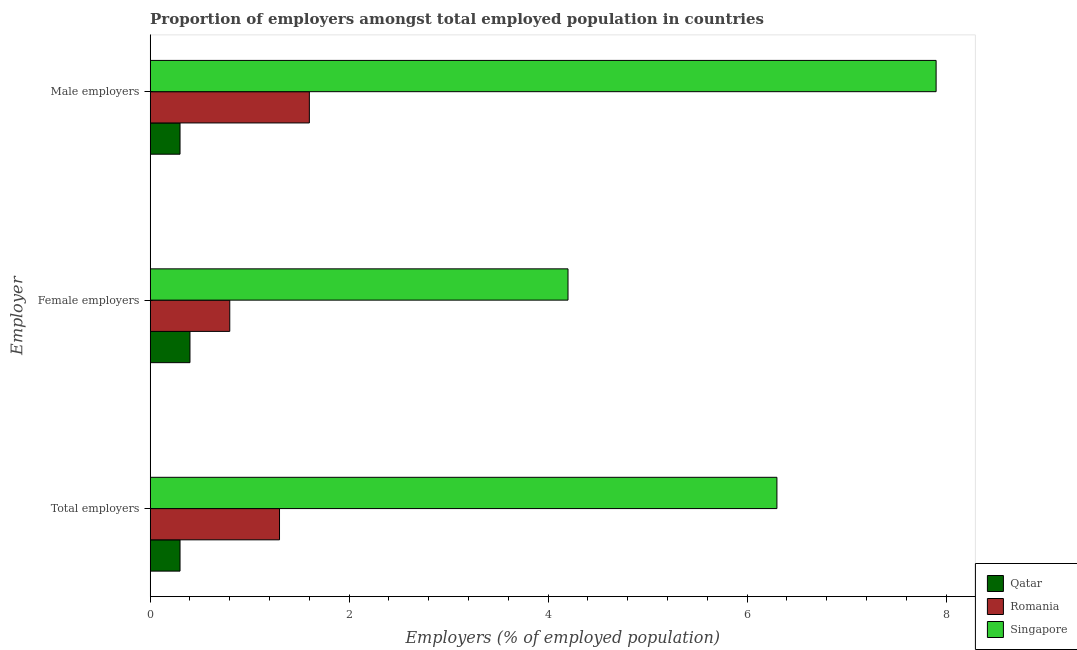How many groups of bars are there?
Make the answer very short. 3. Are the number of bars on each tick of the Y-axis equal?
Make the answer very short. Yes. What is the label of the 2nd group of bars from the top?
Ensure brevity in your answer.  Female employers. What is the percentage of total employers in Qatar?
Your response must be concise. 0.3. Across all countries, what is the maximum percentage of female employers?
Give a very brief answer. 4.2. Across all countries, what is the minimum percentage of male employers?
Your response must be concise. 0.3. In which country was the percentage of male employers maximum?
Keep it short and to the point. Singapore. In which country was the percentage of total employers minimum?
Keep it short and to the point. Qatar. What is the total percentage of male employers in the graph?
Ensure brevity in your answer.  9.8. What is the difference between the percentage of male employers in Romania and that in Singapore?
Provide a short and direct response. -6.3. What is the difference between the percentage of male employers in Romania and the percentage of total employers in Singapore?
Make the answer very short. -4.7. What is the average percentage of total employers per country?
Provide a short and direct response. 2.63. What is the difference between the percentage of male employers and percentage of total employers in Romania?
Offer a very short reply. 0.3. What is the ratio of the percentage of male employers in Singapore to that in Romania?
Offer a very short reply. 4.94. What is the difference between the highest and the second highest percentage of male employers?
Provide a succinct answer. 6.3. What is the difference between the highest and the lowest percentage of female employers?
Your answer should be very brief. 3.8. In how many countries, is the percentage of total employers greater than the average percentage of total employers taken over all countries?
Offer a terse response. 1. What does the 1st bar from the top in Female employers represents?
Provide a succinct answer. Singapore. What does the 3rd bar from the bottom in Total employers represents?
Make the answer very short. Singapore. How many bars are there?
Your response must be concise. 9. Are all the bars in the graph horizontal?
Your answer should be compact. Yes. Does the graph contain grids?
Provide a succinct answer. No. Where does the legend appear in the graph?
Offer a very short reply. Bottom right. How many legend labels are there?
Provide a succinct answer. 3. How are the legend labels stacked?
Offer a very short reply. Vertical. What is the title of the graph?
Your answer should be very brief. Proportion of employers amongst total employed population in countries. What is the label or title of the X-axis?
Provide a succinct answer. Employers (% of employed population). What is the label or title of the Y-axis?
Your response must be concise. Employer. What is the Employers (% of employed population) of Qatar in Total employers?
Ensure brevity in your answer.  0.3. What is the Employers (% of employed population) in Romania in Total employers?
Your answer should be compact. 1.3. What is the Employers (% of employed population) in Singapore in Total employers?
Provide a short and direct response. 6.3. What is the Employers (% of employed population) of Qatar in Female employers?
Give a very brief answer. 0.4. What is the Employers (% of employed population) of Romania in Female employers?
Give a very brief answer. 0.8. What is the Employers (% of employed population) in Singapore in Female employers?
Your answer should be compact. 4.2. What is the Employers (% of employed population) of Qatar in Male employers?
Make the answer very short. 0.3. What is the Employers (% of employed population) in Romania in Male employers?
Give a very brief answer. 1.6. What is the Employers (% of employed population) in Singapore in Male employers?
Offer a terse response. 7.9. Across all Employer, what is the maximum Employers (% of employed population) of Qatar?
Provide a short and direct response. 0.4. Across all Employer, what is the maximum Employers (% of employed population) of Romania?
Your answer should be compact. 1.6. Across all Employer, what is the maximum Employers (% of employed population) in Singapore?
Provide a succinct answer. 7.9. Across all Employer, what is the minimum Employers (% of employed population) of Qatar?
Make the answer very short. 0.3. Across all Employer, what is the minimum Employers (% of employed population) in Romania?
Your response must be concise. 0.8. Across all Employer, what is the minimum Employers (% of employed population) of Singapore?
Provide a short and direct response. 4.2. What is the total Employers (% of employed population) in Singapore in the graph?
Offer a very short reply. 18.4. What is the difference between the Employers (% of employed population) in Qatar in Total employers and that in Female employers?
Offer a terse response. -0.1. What is the difference between the Employers (% of employed population) in Romania in Total employers and that in Female employers?
Your answer should be compact. 0.5. What is the difference between the Employers (% of employed population) in Qatar in Total employers and that in Male employers?
Give a very brief answer. 0. What is the difference between the Employers (% of employed population) in Romania in Total employers and that in Male employers?
Ensure brevity in your answer.  -0.3. What is the difference between the Employers (% of employed population) of Singapore in Total employers and that in Male employers?
Your response must be concise. -1.6. What is the difference between the Employers (% of employed population) of Qatar in Total employers and the Employers (% of employed population) of Romania in Female employers?
Your answer should be very brief. -0.5. What is the difference between the Employers (% of employed population) in Qatar in Total employers and the Employers (% of employed population) in Singapore in Female employers?
Your answer should be very brief. -3.9. What is the difference between the Employers (% of employed population) of Romania in Total employers and the Employers (% of employed population) of Singapore in Female employers?
Your answer should be very brief. -2.9. What is the average Employers (% of employed population) in Romania per Employer?
Provide a short and direct response. 1.23. What is the average Employers (% of employed population) in Singapore per Employer?
Keep it short and to the point. 6.13. What is the difference between the Employers (% of employed population) in Qatar and Employers (% of employed population) in Singapore in Total employers?
Ensure brevity in your answer.  -6. What is the difference between the Employers (% of employed population) in Romania and Employers (% of employed population) in Singapore in Total employers?
Provide a short and direct response. -5. What is the difference between the Employers (% of employed population) in Qatar and Employers (% of employed population) in Romania in Female employers?
Provide a short and direct response. -0.4. What is the difference between the Employers (% of employed population) of Romania and Employers (% of employed population) of Singapore in Female employers?
Make the answer very short. -3.4. What is the difference between the Employers (% of employed population) of Qatar and Employers (% of employed population) of Romania in Male employers?
Ensure brevity in your answer.  -1.3. What is the ratio of the Employers (% of employed population) of Romania in Total employers to that in Female employers?
Make the answer very short. 1.62. What is the ratio of the Employers (% of employed population) in Qatar in Total employers to that in Male employers?
Provide a short and direct response. 1. What is the ratio of the Employers (% of employed population) of Romania in Total employers to that in Male employers?
Make the answer very short. 0.81. What is the ratio of the Employers (% of employed population) in Singapore in Total employers to that in Male employers?
Make the answer very short. 0.8. What is the ratio of the Employers (% of employed population) of Romania in Female employers to that in Male employers?
Give a very brief answer. 0.5. What is the ratio of the Employers (% of employed population) in Singapore in Female employers to that in Male employers?
Give a very brief answer. 0.53. What is the difference between the highest and the second highest Employers (% of employed population) in Qatar?
Provide a short and direct response. 0.1. What is the difference between the highest and the lowest Employers (% of employed population) in Romania?
Offer a very short reply. 0.8. What is the difference between the highest and the lowest Employers (% of employed population) of Singapore?
Give a very brief answer. 3.7. 